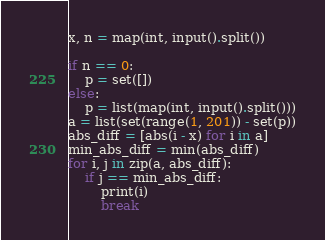<code> <loc_0><loc_0><loc_500><loc_500><_Python_>x, n = map(int, input().split())

if n == 0:
    p = set([])
else:
    p = list(map(int, input().split()))
a = list(set(range(1, 201)) - set(p))
abs_diff = [abs(i - x) for i in a]
min_abs_diff = min(abs_diff)
for i, j in zip(a, abs_diff):
    if j == min_abs_diff:
        print(i)
        break
</code> 